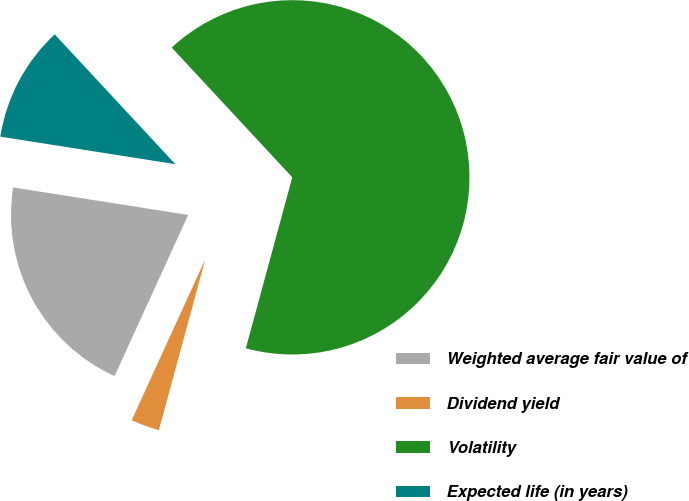Convert chart to OTSL. <chart><loc_0><loc_0><loc_500><loc_500><pie_chart><fcel>Weighted average fair value of<fcel>Dividend yield<fcel>Volatility<fcel>Expected life (in years)<nl><fcel>20.66%<fcel>2.6%<fcel>66.14%<fcel>10.6%<nl></chart> 